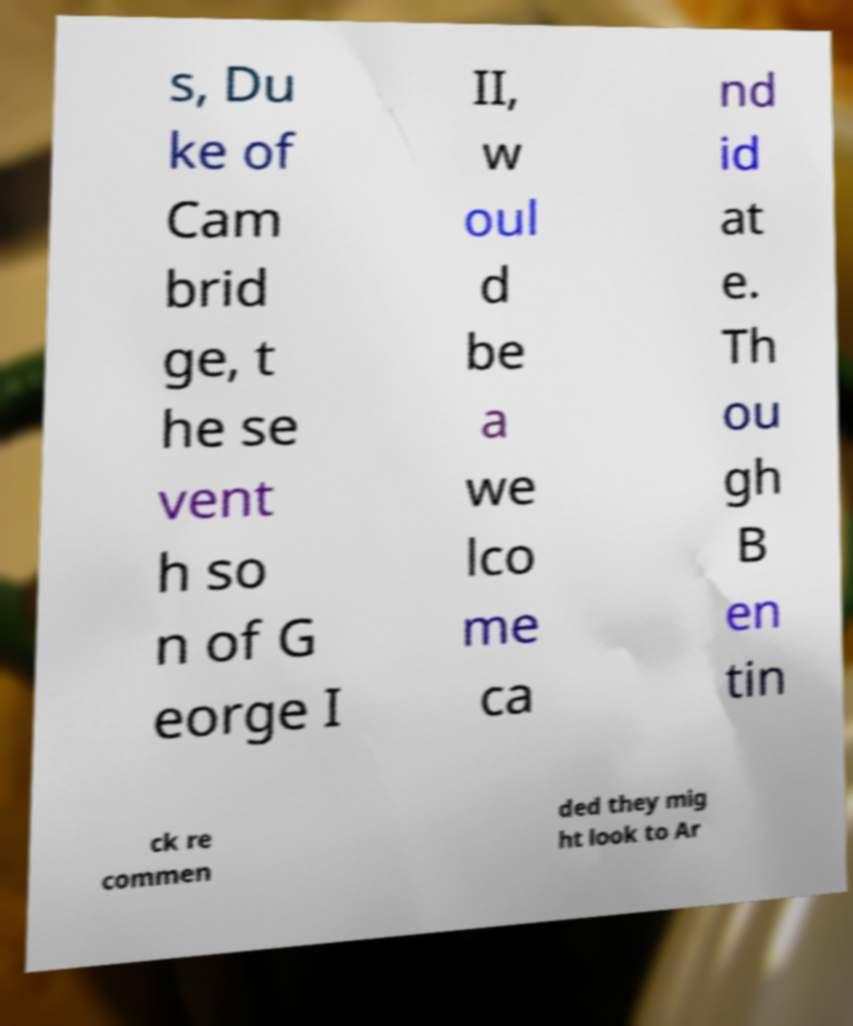What messages or text are displayed in this image? I need them in a readable, typed format. s, Du ke of Cam brid ge, t he se vent h so n of G eorge I II, w oul d be a we lco me ca nd id at e. Th ou gh B en tin ck re commen ded they mig ht look to Ar 